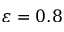Convert formula to latex. <formula><loc_0><loc_0><loc_500><loc_500>\varepsilon = 0 . 8</formula> 